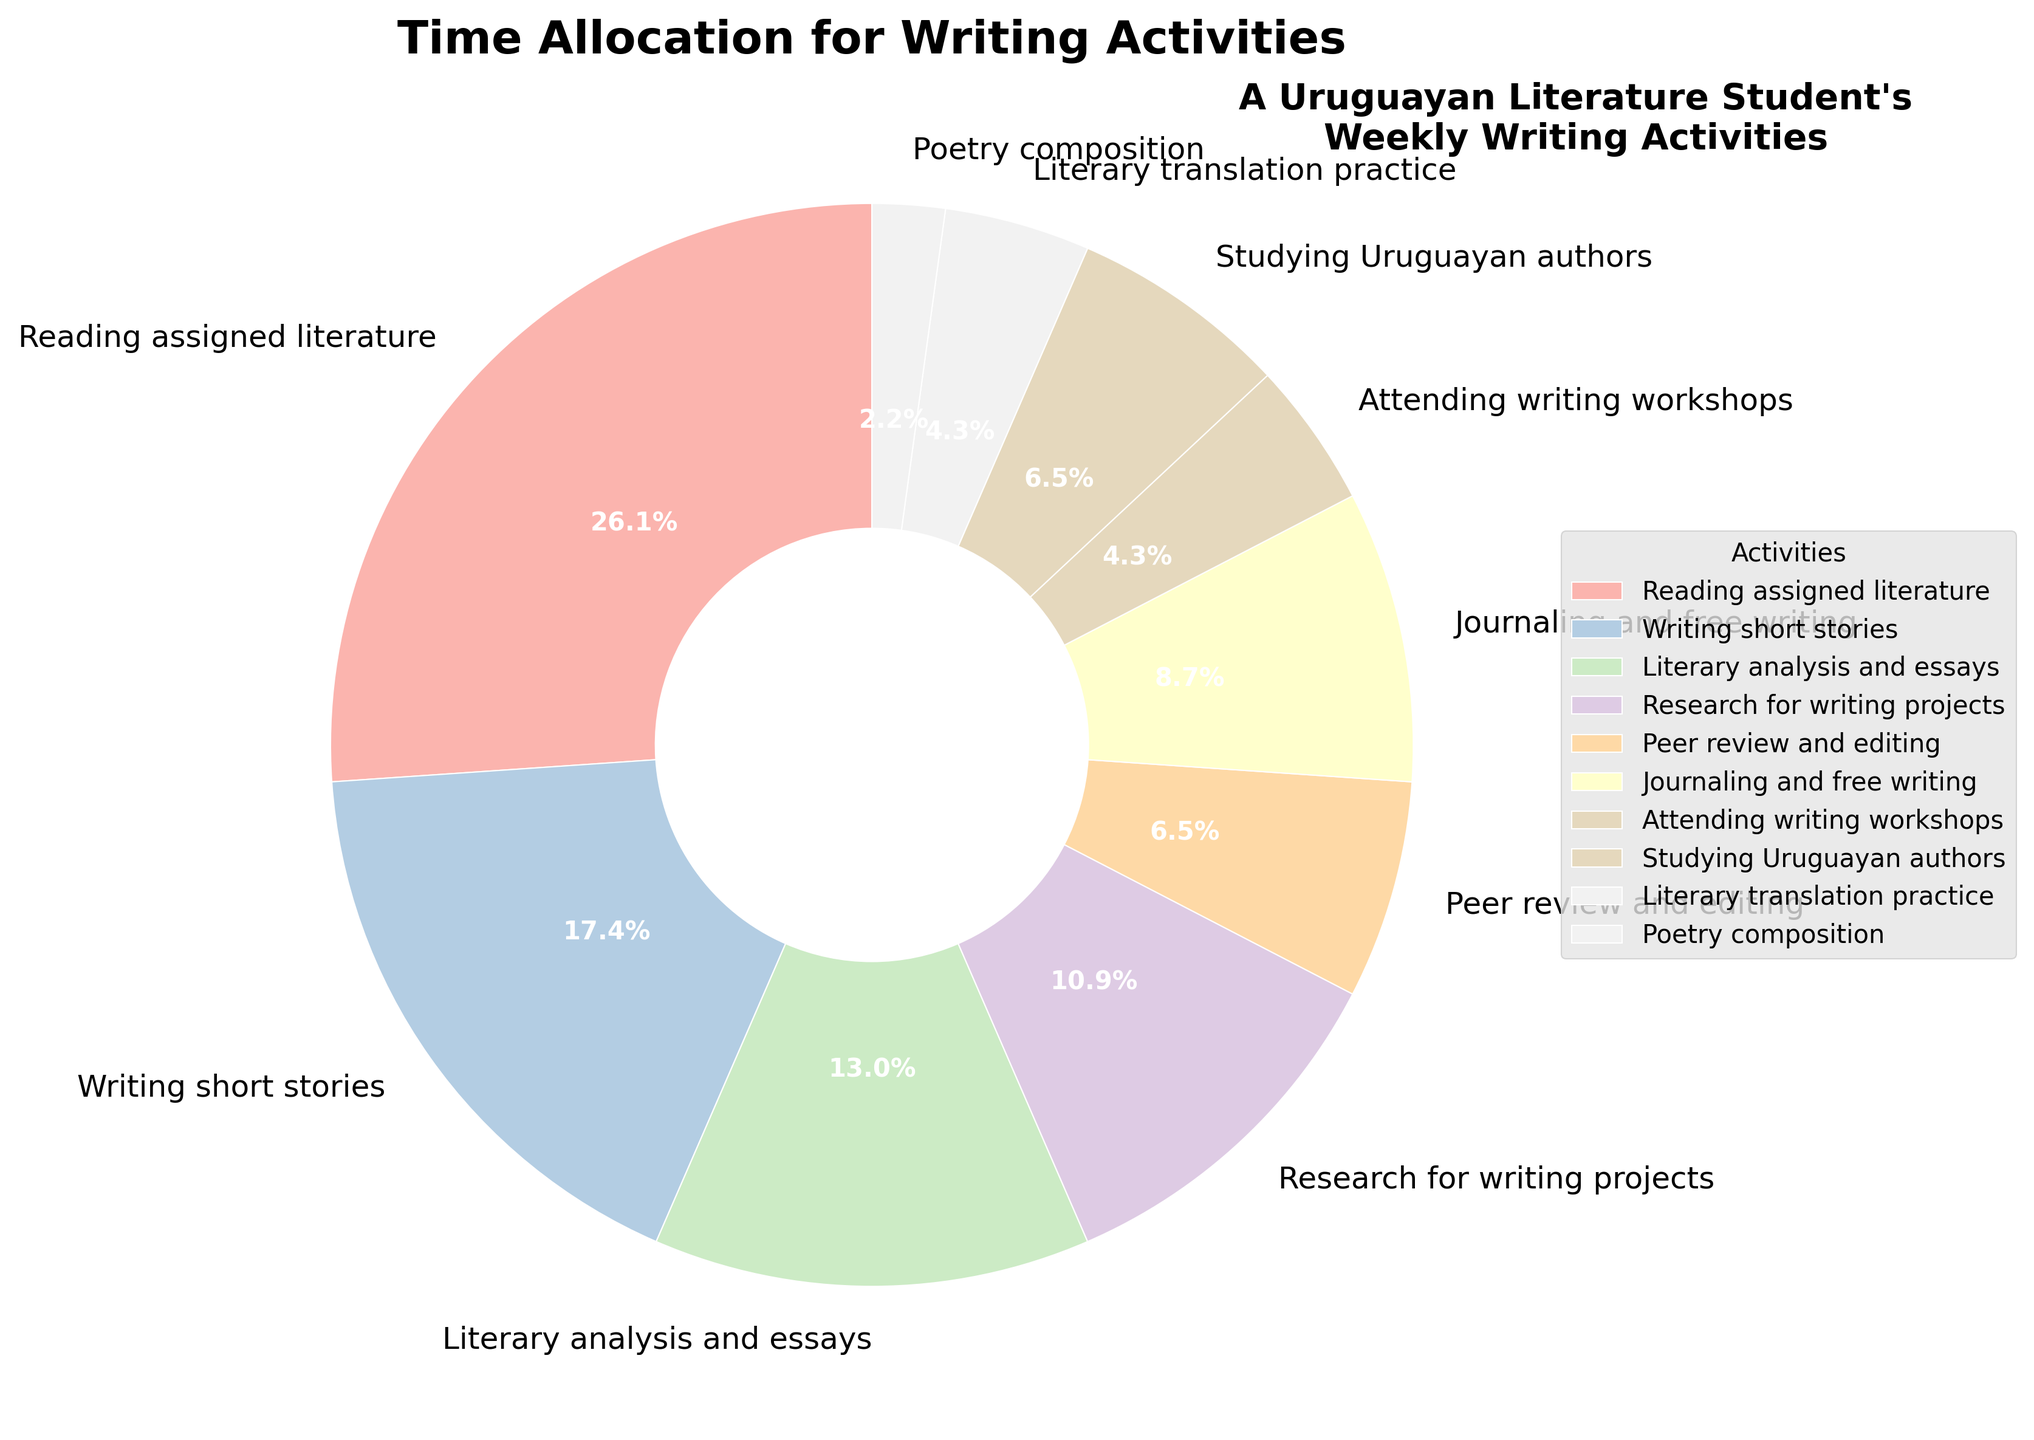Which activity takes up the most time weekly? The largest slice of the pie chart corresponds to the activity with the most hours per week. In this case, "Reading assigned literature" takes up the most time.
Answer: Reading assigned literature How many hours per week does journaling and free writing take compared to poetry composition? Locate "Journaling and free writing" and "Poetry composition" in the pie chart and compare their numeric values. Journaling and free writing take 4 hours per week, while poetry composition takes 1 hour per week, so journaling and free writing take 3 more hours per week.
Answer: 3 more hours Which activity occupies less time: studying Uruguayan authors or attending writing workshops? Compare the pie slices corresponding to "Studying Uruguayan authors" and "Attending writing workshops". Studying Uruguayan authors takes 3 hours per week, and attending writing workshops takes 2 hours per week, so attending writing workshops occupies less time.
Answer: Attending writing workshops What portion of the total time is spent on writing short stories compared to reading assigned literature? Compare the sizes of the pie slices for "Writing short stories" and "Reading assigned literature". Writing short stories takes up 8 hours, while reading assigned literature takes 12 hours. To find the portion, divide 8 by 12: 8/12 = 2/3, so it's two-thirds of the time spent on reading assigned literature.
Answer: Two-thirds How many more hours per week are spent on literary analysis and essays than on literary translation practice? Compare "Literary analysis and essays" and "Literary translation practice" slices. Literary analysis and essays take 6 hours per week, while literary translation practice takes 2 hours per week. The difference is 6 - 2 = 4 hours per week.
Answer: 4 more hours Which two activities each take up the same amount of time? Look for slices of the pie chart that are equal in size. "Attending writing workshops" and "Literary translation practice" each take 2 hours per week.
Answer: Attending writing workshops and Literary translation practice What is the combined time spent on peer review and editing, and journaling and free writing? Add the hours per week for "Peer review and editing" (3 hours) and "Journaling and free writing" (4 hours). The sum is 3 + 4 = 7 hours per week.
Answer: 7 hours Is more time spent on research for writing projects or on studying Uruguayan authors? Compare the pie slices for "Research for writing projects" and "Studying Uruguayan authors". Research for writing projects takes 5 hours per week, while studying Uruguayan authors takes 3 hours per week. Thus, more time is spent on research for writing projects.
Answer: Research for writing projects What is the total percentage of time dedicated to writing short stories and literary analysis and essays? Find the individual percentages for "Writing short stories" and "Literary analysis and essays" (8 hours and 6 hours, respectively). The total weekly hours are 12 + 8 + 6 + 5 + 3 + 4 + 2 + 3 + 2 + 1 = 46 hours. Calculate the percentages: (8/46) * 100 = ~17.4% and (6/46) * 100 = ~13%, summing them gives approximately 30.4%.
Answer: Approximately 30.4% 